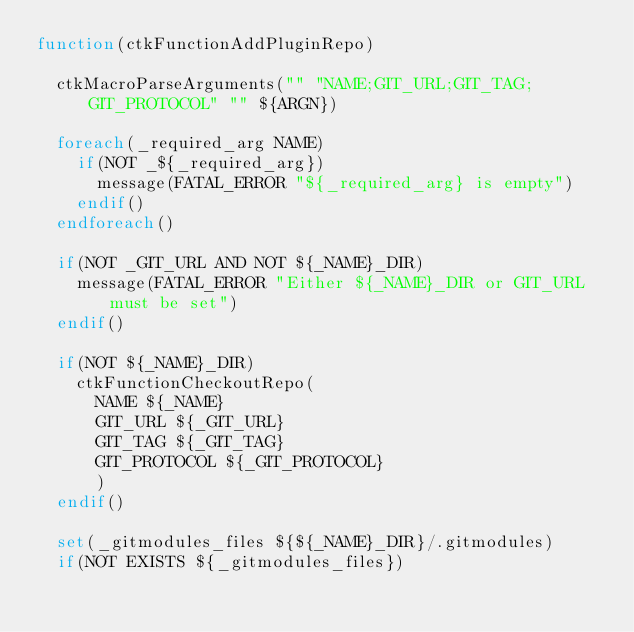Convert code to text. <code><loc_0><loc_0><loc_500><loc_500><_CMake_>function(ctkFunctionAddPluginRepo)

  ctkMacroParseArguments("" "NAME;GIT_URL;GIT_TAG;GIT_PROTOCOL" "" ${ARGN})

  foreach(_required_arg NAME)
    if(NOT _${_required_arg})
      message(FATAL_ERROR "${_required_arg} is empty")
    endif()
  endforeach()

  if(NOT _GIT_URL AND NOT ${_NAME}_DIR)
    message(FATAL_ERROR "Either ${_NAME}_DIR or GIT_URL must be set")
  endif()

  if(NOT ${_NAME}_DIR)
    ctkFunctionCheckoutRepo(
      NAME ${_NAME}
      GIT_URL ${_GIT_URL}
      GIT_TAG ${_GIT_TAG}
      GIT_PROTOCOL ${_GIT_PROTOCOL}
      )
  endif()

  set(_gitmodules_files ${${_NAME}_DIR}/.gitmodules)
  if(NOT EXISTS ${_gitmodules_files})</code> 